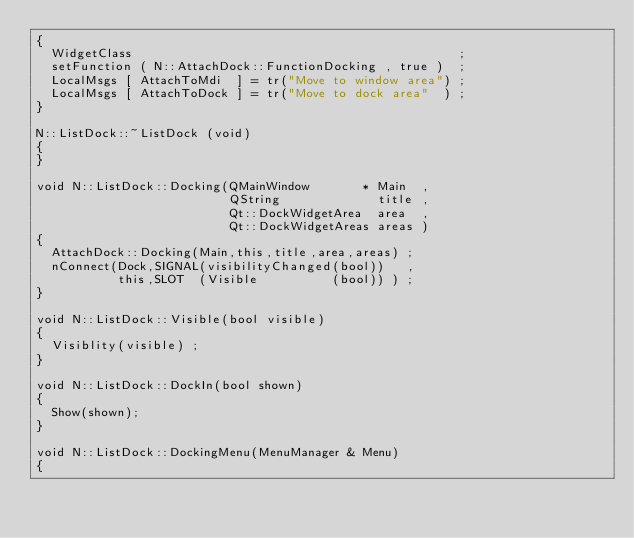<code> <loc_0><loc_0><loc_500><loc_500><_C++_>{
  WidgetClass                                            ;
  setFunction ( N::AttachDock::FunctionDocking , true )  ;
  LocalMsgs [ AttachToMdi  ] = tr("Move to window area") ;
  LocalMsgs [ AttachToDock ] = tr("Move to dock area"  ) ;
}

N::ListDock::~ListDock (void)
{
}

void N::ListDock::Docking(QMainWindow       * Main  ,
                          QString             title ,
                          Qt::DockWidgetArea  area  ,
                          Qt::DockWidgetAreas areas )
{
  AttachDock::Docking(Main,this,title,area,areas) ;
  nConnect(Dock,SIGNAL(visibilityChanged(bool))   ,
           this,SLOT  (Visible          (bool)) ) ;
}

void N::ListDock::Visible(bool visible)
{
  Visiblity(visible) ;
}

void N::ListDock::DockIn(bool shown)
{
  Show(shown);
}

void N::ListDock::DockingMenu(MenuManager & Menu)
{</code> 